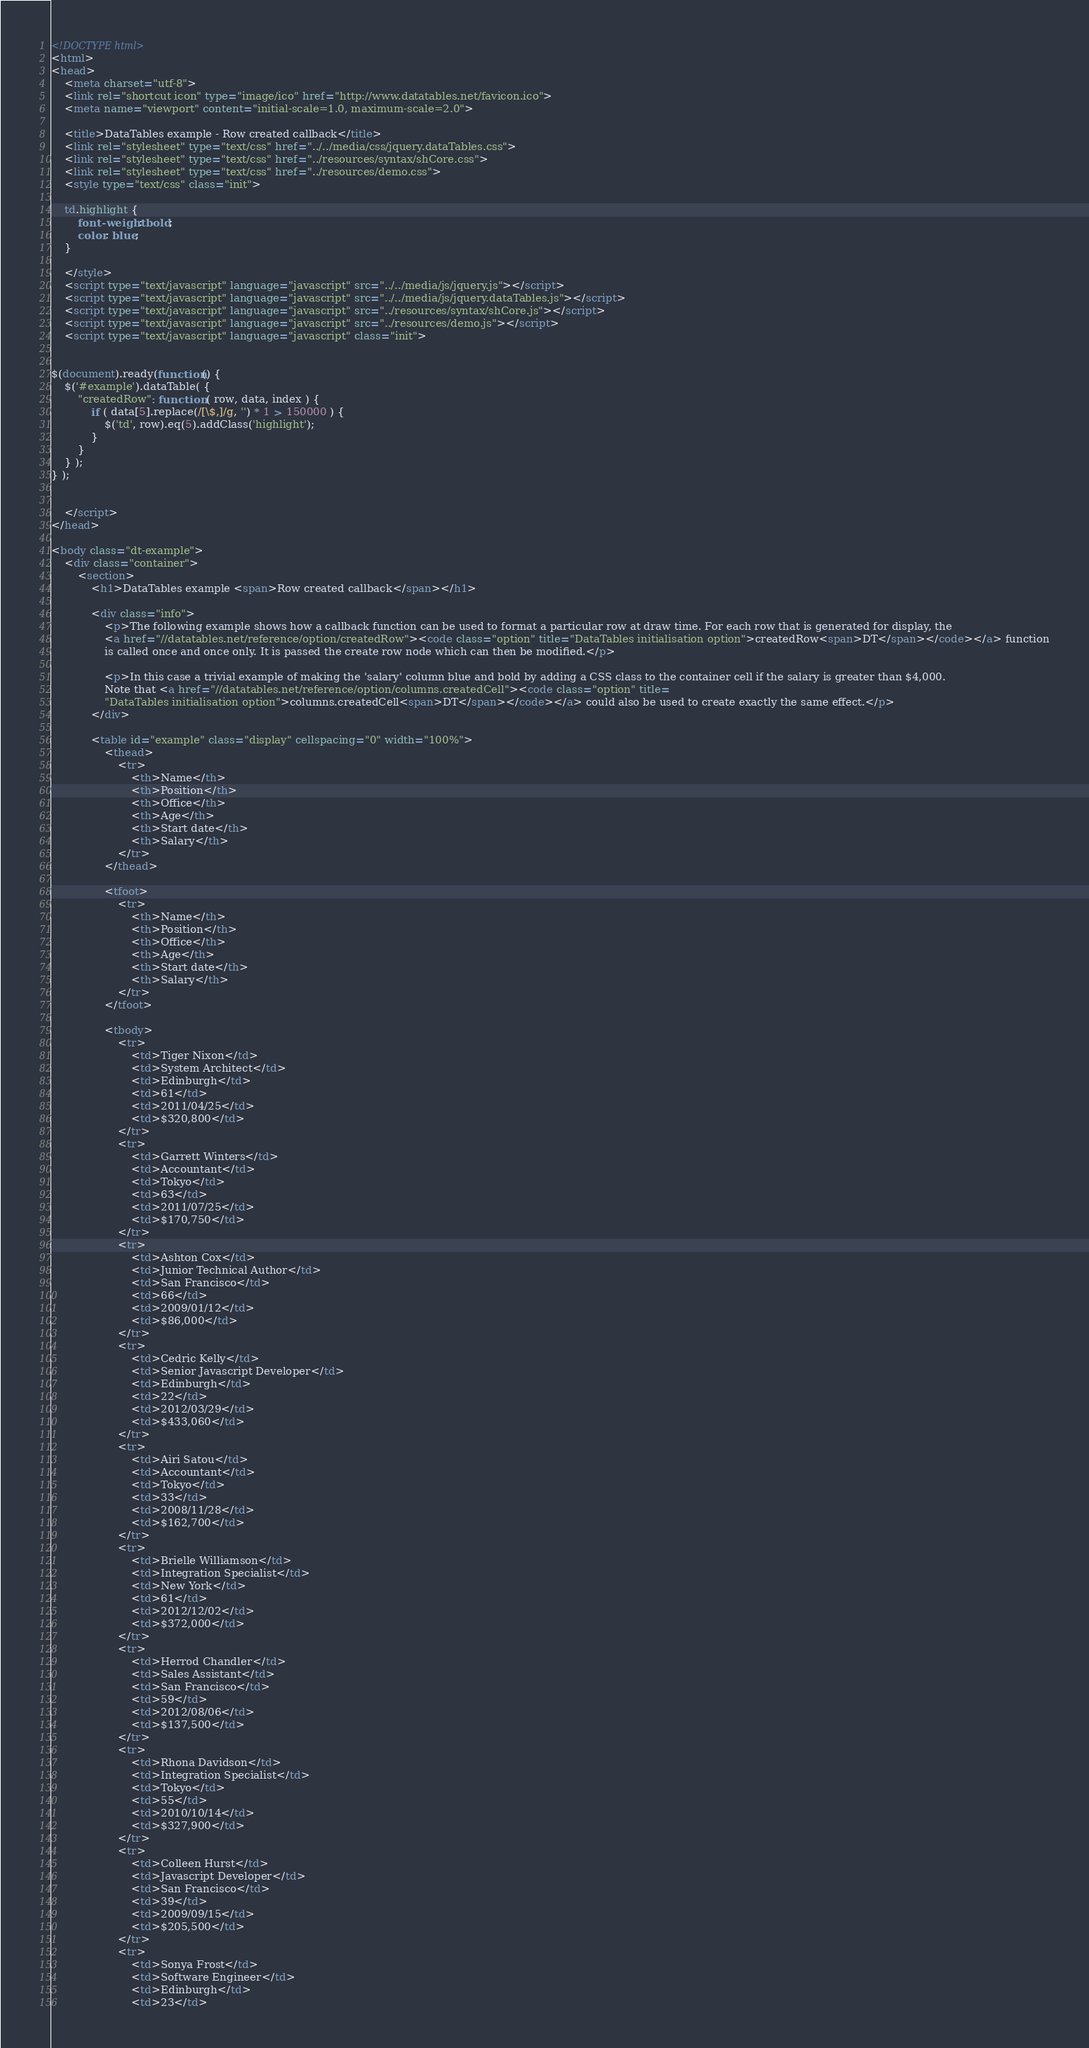Convert code to text. <code><loc_0><loc_0><loc_500><loc_500><_HTML_><!DOCTYPE html>
<html>
<head>
	<meta charset="utf-8">
	<link rel="shortcut icon" type="image/ico" href="http://www.datatables.net/favicon.ico">
	<meta name="viewport" content="initial-scale=1.0, maximum-scale=2.0">

	<title>DataTables example - Row created callback</title>
	<link rel="stylesheet" type="text/css" href="../../media/css/jquery.dataTables.css">
	<link rel="stylesheet" type="text/css" href="../resources/syntax/shCore.css">
	<link rel="stylesheet" type="text/css" href="../resources/demo.css">
	<style type="text/css" class="init">

	td.highlight {
		font-weight: bold;
		color: blue;
	}

	</style>
	<script type="text/javascript" language="javascript" src="../../media/js/jquery.js"></script>
	<script type="text/javascript" language="javascript" src="../../media/js/jquery.dataTables.js"></script>
	<script type="text/javascript" language="javascript" src="../resources/syntax/shCore.js"></script>
	<script type="text/javascript" language="javascript" src="../resources/demo.js"></script>
	<script type="text/javascript" language="javascript" class="init">


$(document).ready(function() {
	$('#example').dataTable( {
		"createdRow": function ( row, data, index ) {
			if ( data[5].replace(/[\$,]/g, '') * 1 > 150000 ) {
				$('td', row).eq(5).addClass('highlight');
			}
		}
	} );
} );


	</script>
</head>

<body class="dt-example">
	<div class="container">
		<section>
			<h1>DataTables example <span>Row created callback</span></h1>

			<div class="info">
				<p>The following example shows how a callback function can be used to format a particular row at draw time. For each row that is generated for display, the
				<a href="//datatables.net/reference/option/createdRow"><code class="option" title="DataTables initialisation option">createdRow<span>DT</span></code></a> function
				is called once and once only. It is passed the create row node which can then be modified.</p>

				<p>In this case a trivial example of making the 'salary' column blue and bold by adding a CSS class to the container cell if the salary is greater than $4,000.
				Note that <a href="//datatables.net/reference/option/columns.createdCell"><code class="option" title=
				"DataTables initialisation option">columns.createdCell<span>DT</span></code></a> could also be used to create exactly the same effect.</p>
			</div>

			<table id="example" class="display" cellspacing="0" width="100%">
				<thead>
					<tr>
						<th>Name</th>
						<th>Position</th>
						<th>Office</th>
						<th>Age</th>
						<th>Start date</th>
						<th>Salary</th>
					</tr>
				</thead>

				<tfoot>
					<tr>
						<th>Name</th>
						<th>Position</th>
						<th>Office</th>
						<th>Age</th>
						<th>Start date</th>
						<th>Salary</th>
					</tr>
				</tfoot>

				<tbody>
					<tr>
						<td>Tiger Nixon</td>
						<td>System Architect</td>
						<td>Edinburgh</td>
						<td>61</td>
						<td>2011/04/25</td>
						<td>$320,800</td>
					</tr>
					<tr>
						<td>Garrett Winters</td>
						<td>Accountant</td>
						<td>Tokyo</td>
						<td>63</td>
						<td>2011/07/25</td>
						<td>$170,750</td>
					</tr>
					<tr>
						<td>Ashton Cox</td>
						<td>Junior Technical Author</td>
						<td>San Francisco</td>
						<td>66</td>
						<td>2009/01/12</td>
						<td>$86,000</td>
					</tr>
					<tr>
						<td>Cedric Kelly</td>
						<td>Senior Javascript Developer</td>
						<td>Edinburgh</td>
						<td>22</td>
						<td>2012/03/29</td>
						<td>$433,060</td>
					</tr>
					<tr>
						<td>Airi Satou</td>
						<td>Accountant</td>
						<td>Tokyo</td>
						<td>33</td>
						<td>2008/11/28</td>
						<td>$162,700</td>
					</tr>
					<tr>
						<td>Brielle Williamson</td>
						<td>Integration Specialist</td>
						<td>New York</td>
						<td>61</td>
						<td>2012/12/02</td>
						<td>$372,000</td>
					</tr>
					<tr>
						<td>Herrod Chandler</td>
						<td>Sales Assistant</td>
						<td>San Francisco</td>
						<td>59</td>
						<td>2012/08/06</td>
						<td>$137,500</td>
					</tr>
					<tr>
						<td>Rhona Davidson</td>
						<td>Integration Specialist</td>
						<td>Tokyo</td>
						<td>55</td>
						<td>2010/10/14</td>
						<td>$327,900</td>
					</tr>
					<tr>
						<td>Colleen Hurst</td>
						<td>Javascript Developer</td>
						<td>San Francisco</td>
						<td>39</td>
						<td>2009/09/15</td>
						<td>$205,500</td>
					</tr>
					<tr>
						<td>Sonya Frost</td>
						<td>Software Engineer</td>
						<td>Edinburgh</td>
						<td>23</td></code> 